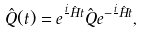Convert formula to latex. <formula><loc_0><loc_0><loc_500><loc_500>\hat { Q } ( t ) = e ^ { \frac { i } { } \hat { H } t } \hat { Q } e ^ { - \frac { i } { } \hat { H } t } ,</formula> 